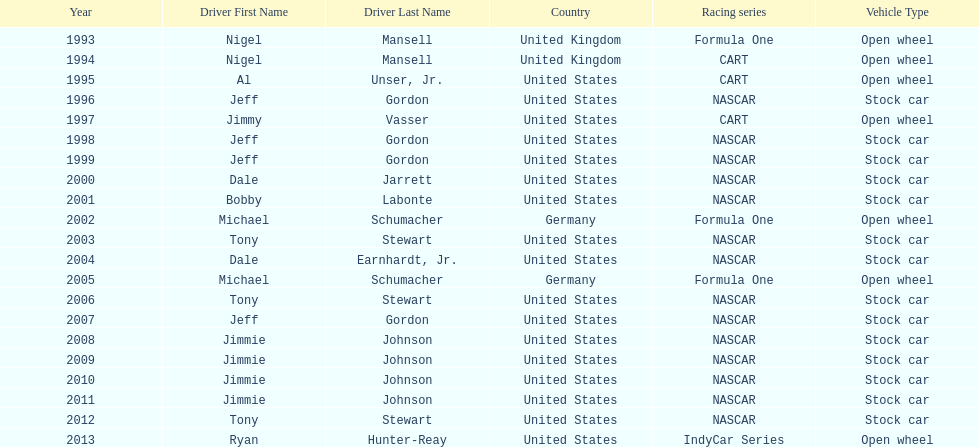Jimmy johnson won how many consecutive espy awards? 4. 